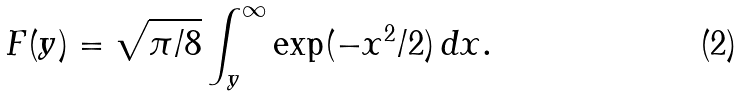<formula> <loc_0><loc_0><loc_500><loc_500>F ( y ) = \sqrt { \pi / 8 } \int _ { y } ^ { \infty } \exp ( - x ^ { 2 } / 2 ) \, d x .</formula> 